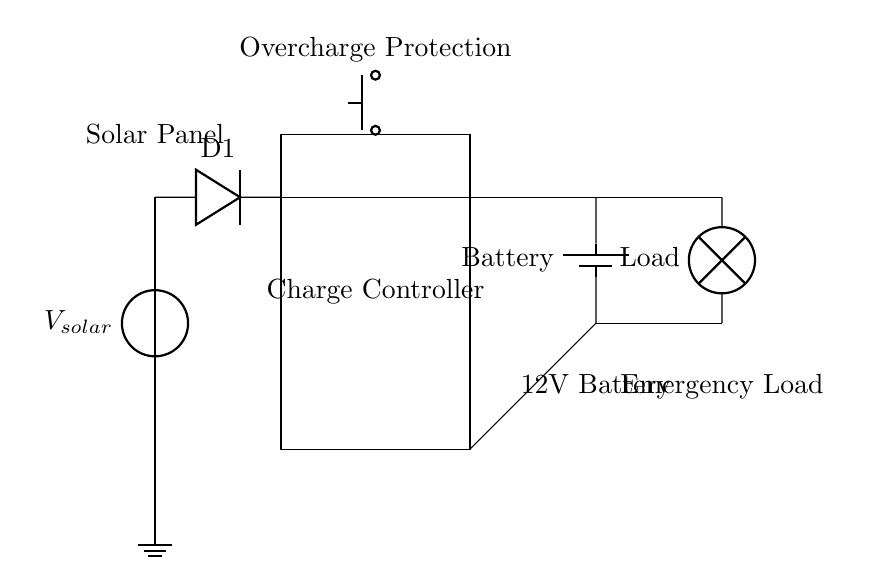What type of energy does the circuit utilize? The circuit utilizes solar energy, as indicated by the presence of the solar panel component in the diagram.
Answer: Solar energy What component protects against battery overcharging? The overcharge protection is implemented using a push button labeled as “Overcharge Protection” located at the charge controller section.
Answer: Push button What is the voltage rating of the battery? The battery is labeled as a 12V battery, which indicates its nominal voltage.
Answer: 12V Which component converts solar energy into electrical energy? The solar panel is responsible for converting solar energy into electrical energy, denoted as V solar in the circuit.
Answer: Solar panel How does the charge controller function in this circuit? The charge controller regulates the voltage and current from the solar panel to the battery, preventing overcharging and providing a stable output.
Answer: Regulates voltage and current What is the emergency load connected to? The emergency load is connected to the output of the battery, allowing it to draw power when necessary.
Answer: Battery What is the purpose of the diode in the circuit? The diode prevents reverse current flow from the battery to the solar panel, ensuring that the battery only charges when there is solar input.
Answer: Prevents reverse current flow 